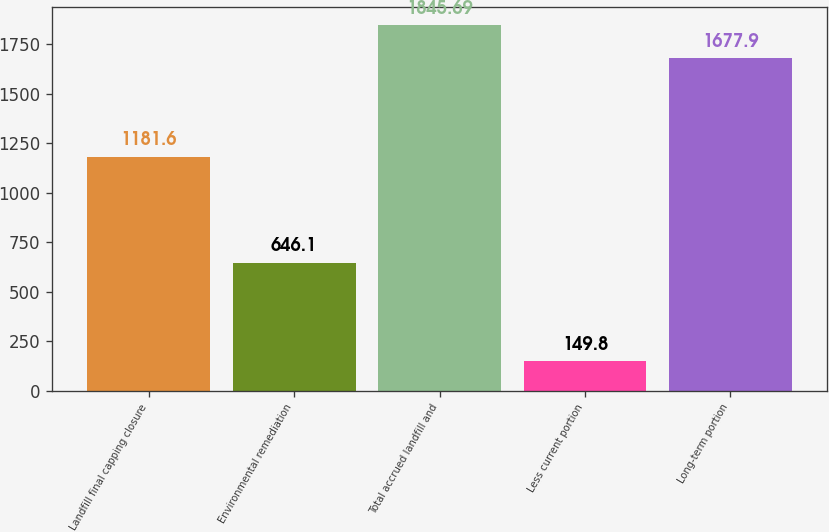Convert chart. <chart><loc_0><loc_0><loc_500><loc_500><bar_chart><fcel>Landfill final capping closure<fcel>Environmental remediation<fcel>Total accrued landfill and<fcel>Less current portion<fcel>Long-term portion<nl><fcel>1181.6<fcel>646.1<fcel>1845.69<fcel>149.8<fcel>1677.9<nl></chart> 